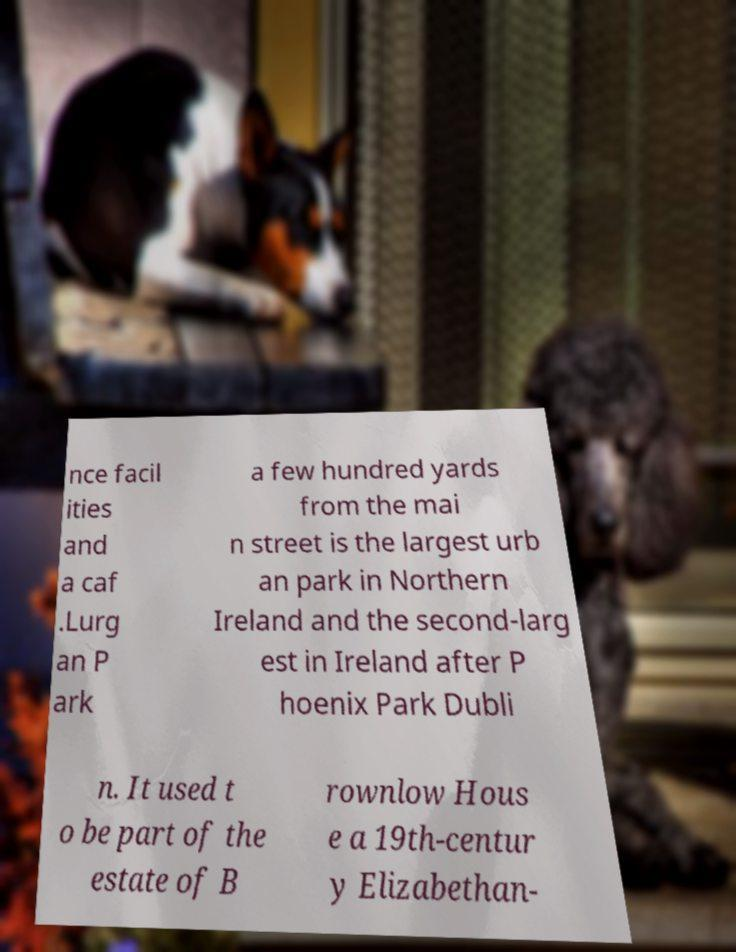Could you extract and type out the text from this image? nce facil ities and a caf .Lurg an P ark a few hundred yards from the mai n street is the largest urb an park in Northern Ireland and the second-larg est in Ireland after P hoenix Park Dubli n. It used t o be part of the estate of B rownlow Hous e a 19th-centur y Elizabethan- 